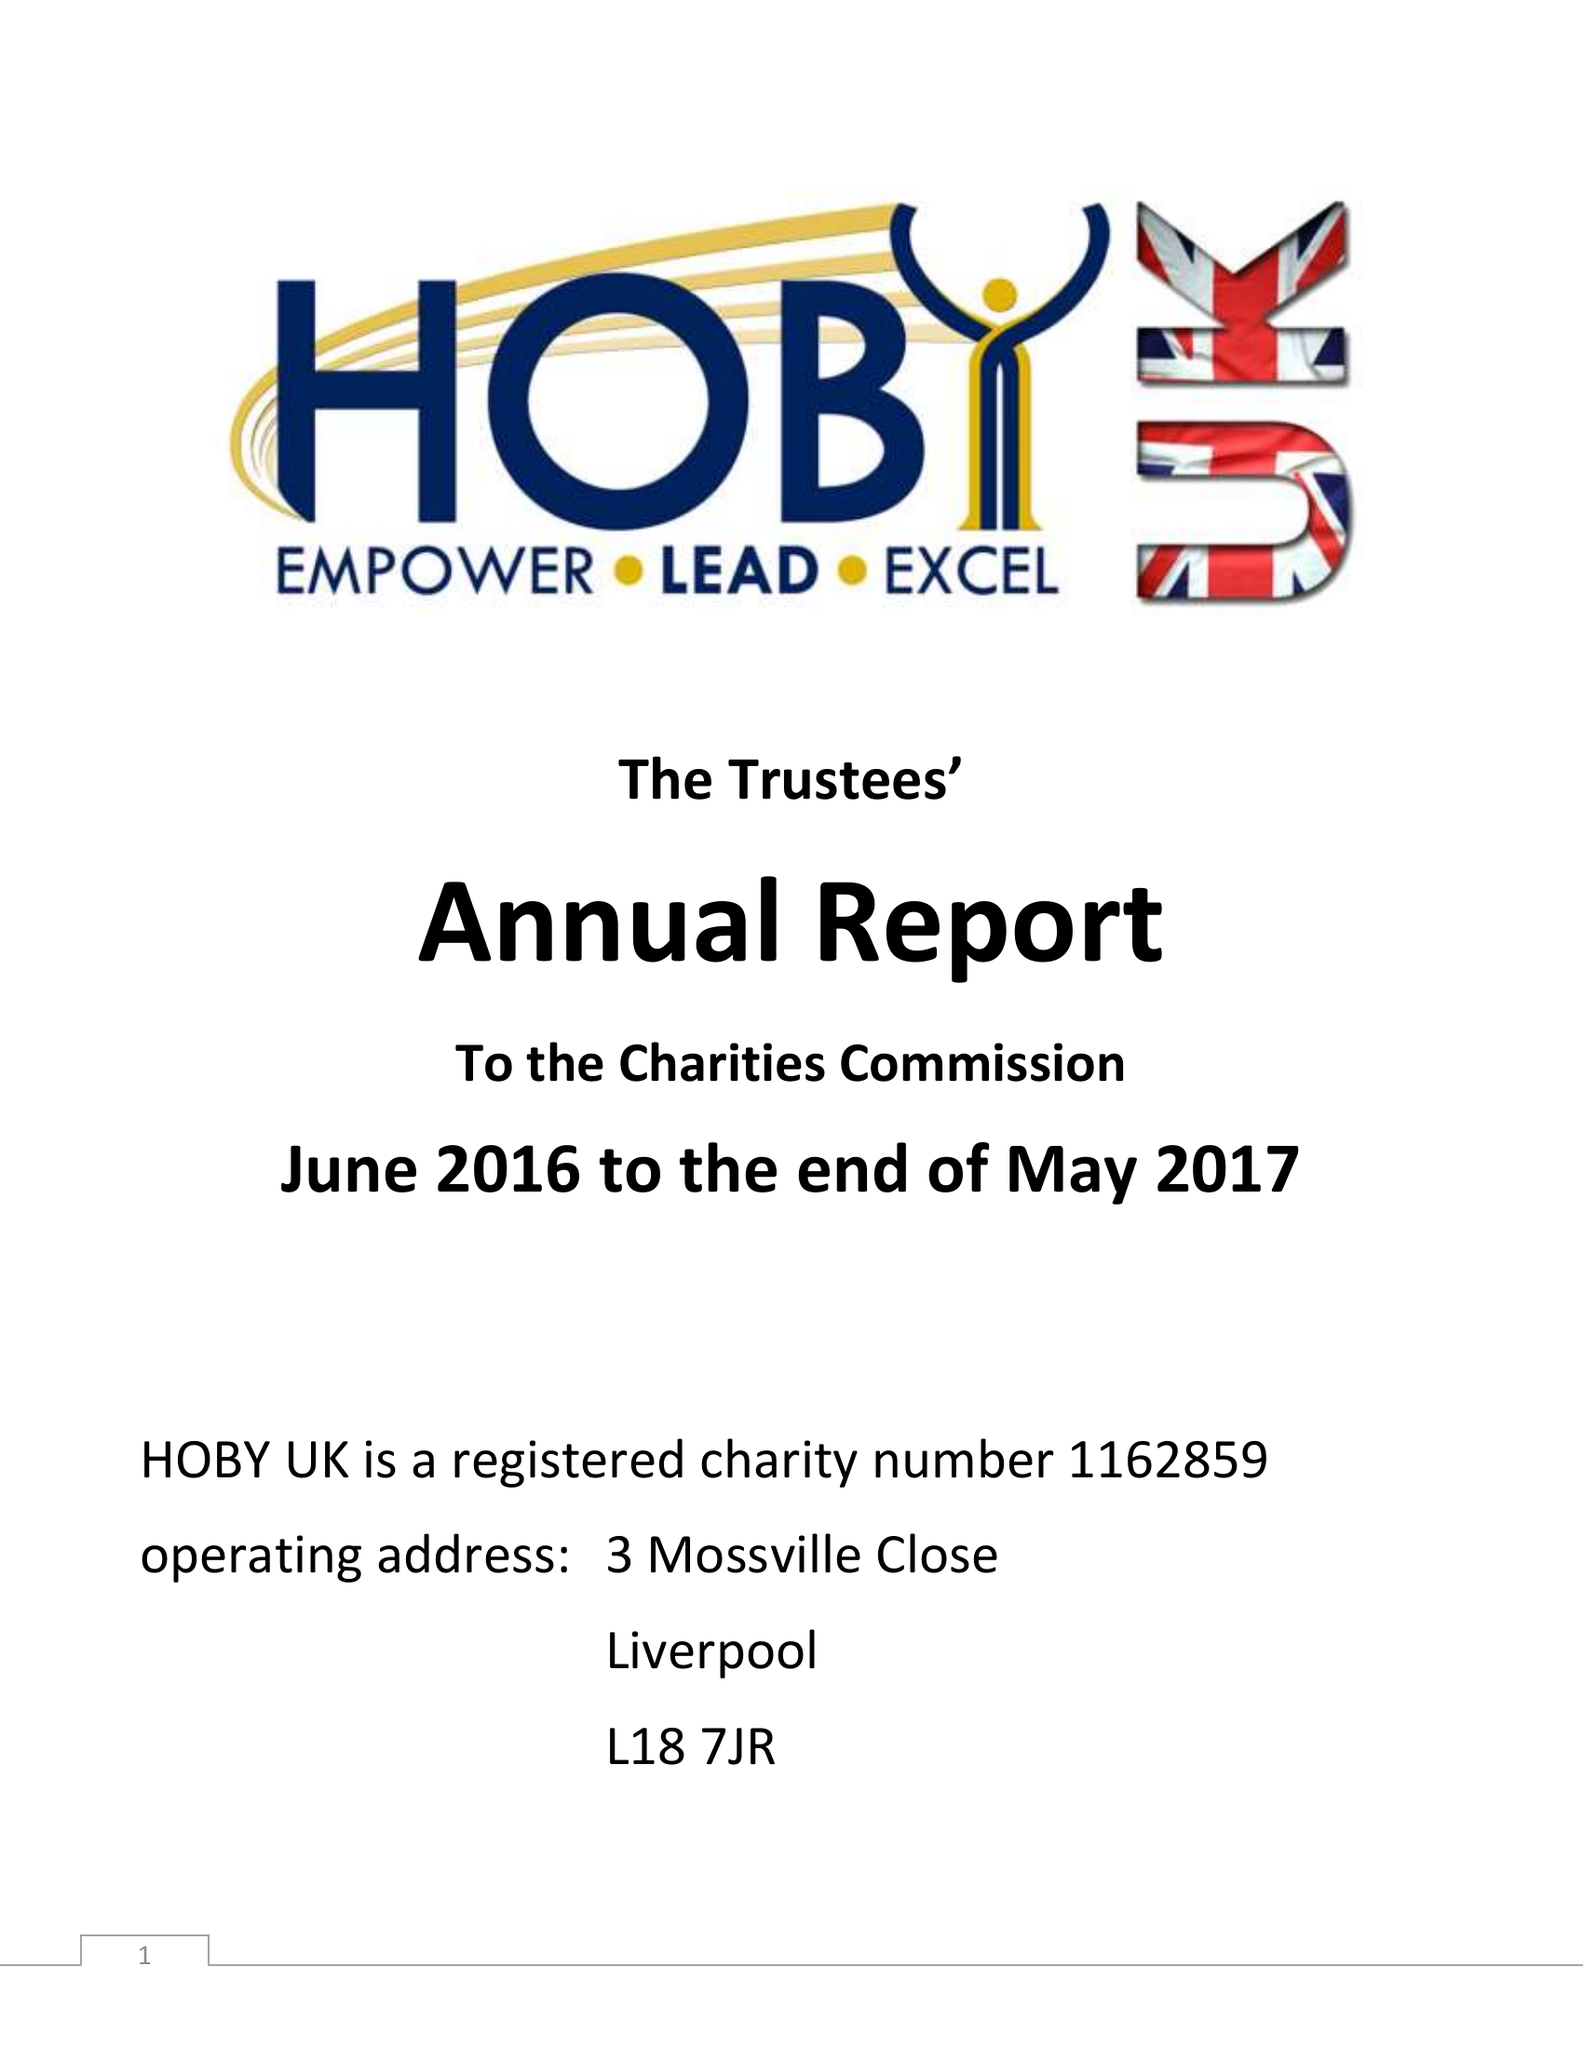What is the value for the spending_annually_in_british_pounds?
Answer the question using a single word or phrase. 5714.49 